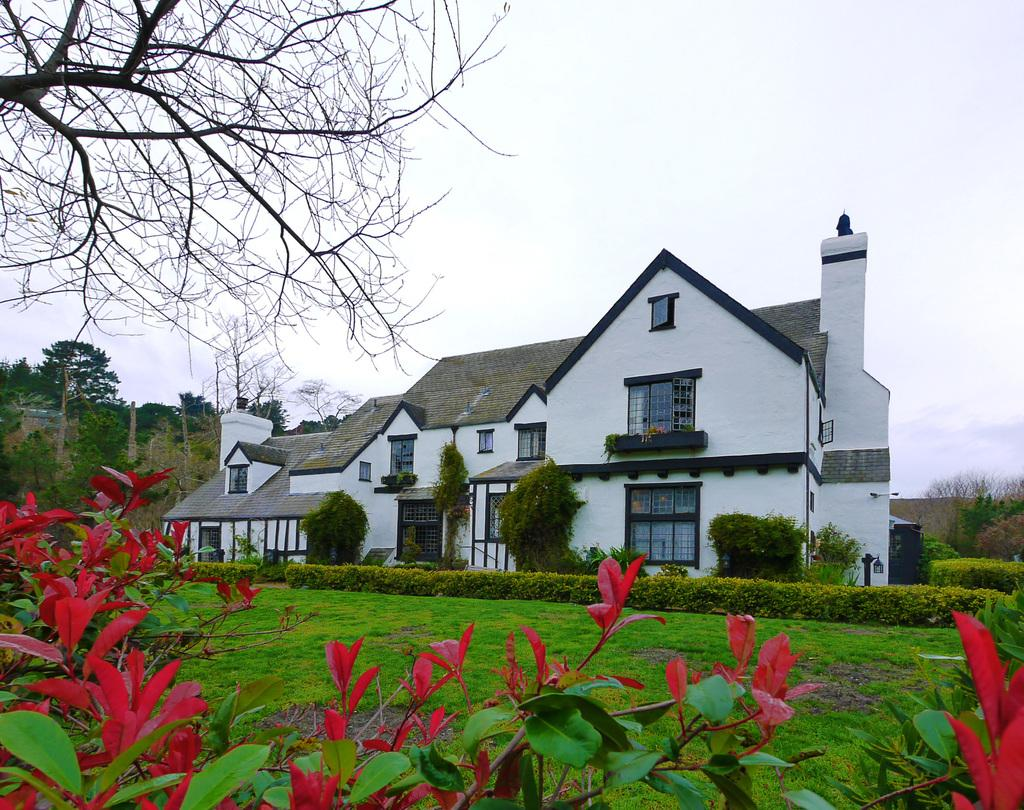What type of structure is in the image? There is a building in the image. What colors are used for the building? The building is in white and gray colors. What can be seen on the left side of the image? There are trees on the left side of the image. What is the color of the trees? The trees are green in color. What part of the natural environment is visible in the image? The sky is visible in the image. What is the color of the sky? The sky is in white color. How many crates are stacked on the right side of the image? There are no crates present in the image. 